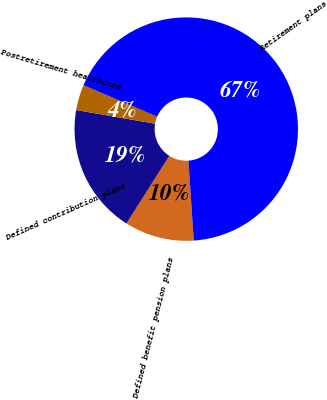Convert chart. <chart><loc_0><loc_0><loc_500><loc_500><pie_chart><fcel>Defined benefit pension plans<fcel>Defined contribution plans<fcel>Postretirement healthcare<fcel>Retirement plans<nl><fcel>10.07%<fcel>18.74%<fcel>3.69%<fcel>67.49%<nl></chart> 